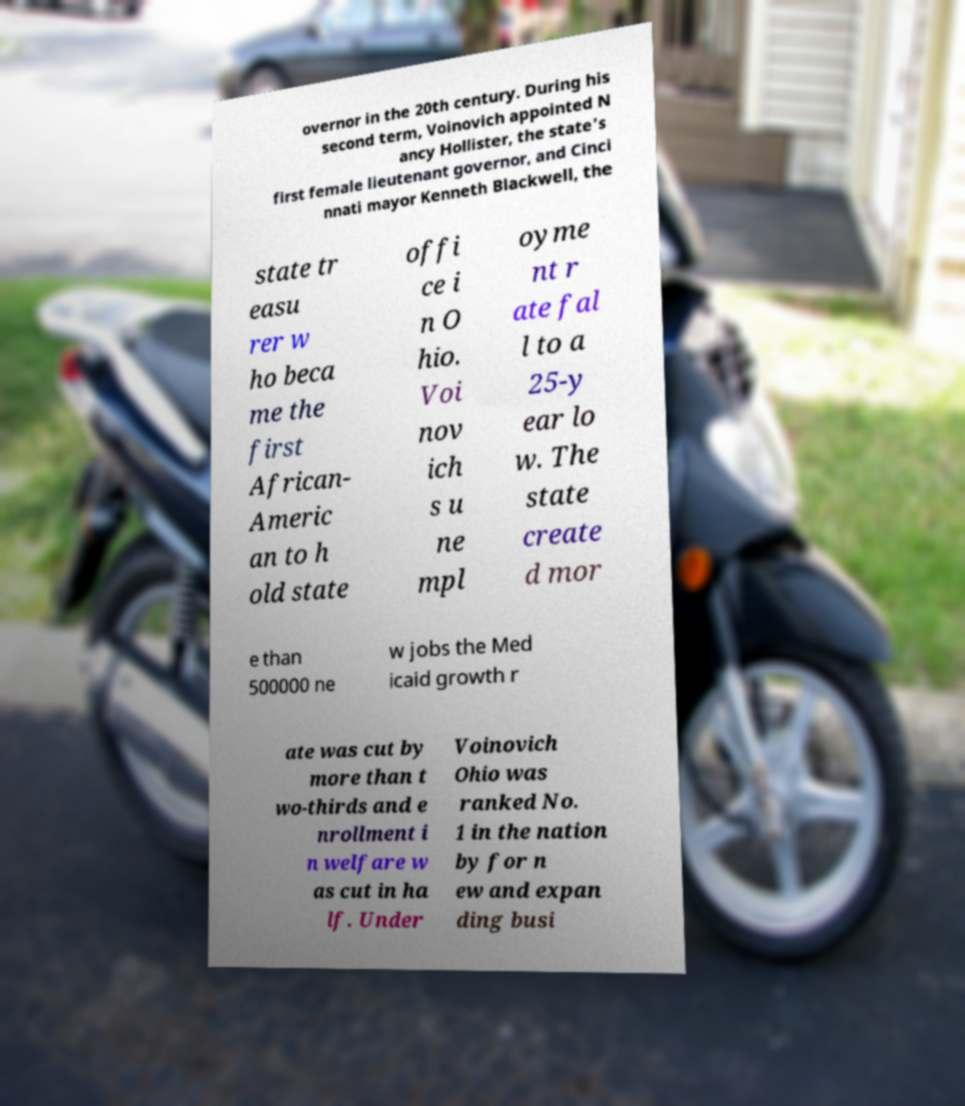Could you extract and type out the text from this image? overnor in the 20th century. During his second term, Voinovich appointed N ancy Hollister, the state's first female lieutenant governor, and Cinci nnati mayor Kenneth Blackwell, the state tr easu rer w ho beca me the first African- Americ an to h old state offi ce i n O hio. Voi nov ich s u ne mpl oyme nt r ate fal l to a 25-y ear lo w. The state create d mor e than 500000 ne w jobs the Med icaid growth r ate was cut by more than t wo-thirds and e nrollment i n welfare w as cut in ha lf. Under Voinovich Ohio was ranked No. 1 in the nation by for n ew and expan ding busi 